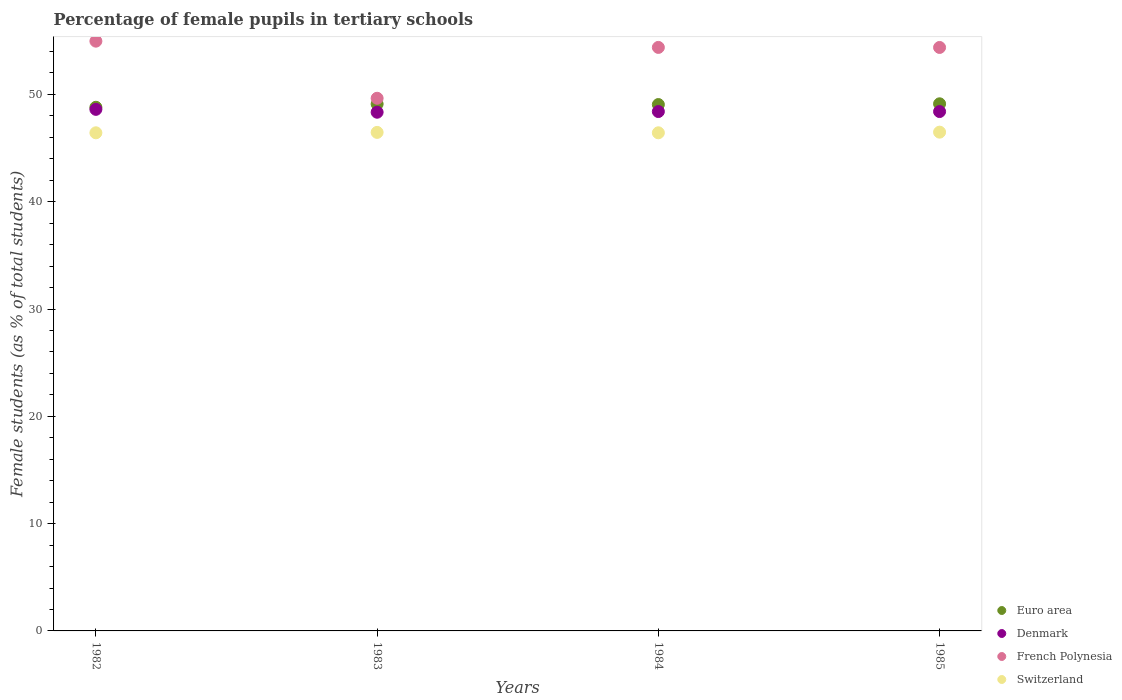How many different coloured dotlines are there?
Provide a succinct answer. 4. What is the percentage of female pupils in tertiary schools in French Polynesia in 1982?
Provide a short and direct response. 54.97. Across all years, what is the maximum percentage of female pupils in tertiary schools in Euro area?
Offer a terse response. 49.13. Across all years, what is the minimum percentage of female pupils in tertiary schools in Switzerland?
Provide a succinct answer. 46.43. In which year was the percentage of female pupils in tertiary schools in Switzerland maximum?
Keep it short and to the point. 1985. In which year was the percentage of female pupils in tertiary schools in Denmark minimum?
Make the answer very short. 1983. What is the total percentage of female pupils in tertiary schools in Denmark in the graph?
Your response must be concise. 193.77. What is the difference between the percentage of female pupils in tertiary schools in Switzerland in 1983 and that in 1985?
Ensure brevity in your answer.  -0.02. What is the difference between the percentage of female pupils in tertiary schools in Euro area in 1985 and the percentage of female pupils in tertiary schools in Switzerland in 1984?
Your response must be concise. 2.7. What is the average percentage of female pupils in tertiary schools in Euro area per year?
Your answer should be very brief. 49.02. In the year 1983, what is the difference between the percentage of female pupils in tertiary schools in Denmark and percentage of female pupils in tertiary schools in Euro area?
Ensure brevity in your answer.  -0.76. In how many years, is the percentage of female pupils in tertiary schools in Switzerland greater than 40 %?
Offer a very short reply. 4. What is the ratio of the percentage of female pupils in tertiary schools in French Polynesia in 1982 to that in 1985?
Your answer should be compact. 1.01. Is the percentage of female pupils in tertiary schools in Denmark in 1983 less than that in 1985?
Ensure brevity in your answer.  Yes. What is the difference between the highest and the second highest percentage of female pupils in tertiary schools in French Polynesia?
Provide a succinct answer. 0.58. What is the difference between the highest and the lowest percentage of female pupils in tertiary schools in French Polynesia?
Your response must be concise. 5.32. Is it the case that in every year, the sum of the percentage of female pupils in tertiary schools in French Polynesia and percentage of female pupils in tertiary schools in Denmark  is greater than the sum of percentage of female pupils in tertiary schools in Switzerland and percentage of female pupils in tertiary schools in Euro area?
Your answer should be very brief. No. Is it the case that in every year, the sum of the percentage of female pupils in tertiary schools in Euro area and percentage of female pupils in tertiary schools in Denmark  is greater than the percentage of female pupils in tertiary schools in French Polynesia?
Give a very brief answer. Yes. Is the percentage of female pupils in tertiary schools in Switzerland strictly greater than the percentage of female pupils in tertiary schools in Euro area over the years?
Keep it short and to the point. No. How many dotlines are there?
Ensure brevity in your answer.  4. What is the difference between two consecutive major ticks on the Y-axis?
Keep it short and to the point. 10. Does the graph contain grids?
Make the answer very short. No. Where does the legend appear in the graph?
Provide a succinct answer. Bottom right. How many legend labels are there?
Offer a very short reply. 4. What is the title of the graph?
Keep it short and to the point. Percentage of female pupils in tertiary schools. Does "Nepal" appear as one of the legend labels in the graph?
Offer a terse response. No. What is the label or title of the Y-axis?
Keep it short and to the point. Female students (as % of total students). What is the Female students (as % of total students) in Euro area in 1982?
Provide a succinct answer. 48.81. What is the Female students (as % of total students) of Denmark in 1982?
Provide a short and direct response. 48.61. What is the Female students (as % of total students) in French Polynesia in 1982?
Offer a very short reply. 54.97. What is the Female students (as % of total students) of Switzerland in 1982?
Keep it short and to the point. 46.43. What is the Female students (as % of total students) in Euro area in 1983?
Make the answer very short. 49.11. What is the Female students (as % of total students) of Denmark in 1983?
Keep it short and to the point. 48.34. What is the Female students (as % of total students) of French Polynesia in 1983?
Your answer should be very brief. 49.64. What is the Female students (as % of total students) of Switzerland in 1983?
Ensure brevity in your answer.  46.46. What is the Female students (as % of total students) in Euro area in 1984?
Keep it short and to the point. 49.06. What is the Female students (as % of total students) in Denmark in 1984?
Offer a very short reply. 48.41. What is the Female students (as % of total students) in French Polynesia in 1984?
Your answer should be compact. 54.38. What is the Female students (as % of total students) in Switzerland in 1984?
Your answer should be very brief. 46.43. What is the Female students (as % of total students) of Euro area in 1985?
Give a very brief answer. 49.13. What is the Female students (as % of total students) in Denmark in 1985?
Provide a short and direct response. 48.41. What is the Female students (as % of total students) in French Polynesia in 1985?
Keep it short and to the point. 54.38. What is the Female students (as % of total students) of Switzerland in 1985?
Ensure brevity in your answer.  46.49. Across all years, what is the maximum Female students (as % of total students) in Euro area?
Ensure brevity in your answer.  49.13. Across all years, what is the maximum Female students (as % of total students) in Denmark?
Ensure brevity in your answer.  48.61. Across all years, what is the maximum Female students (as % of total students) of French Polynesia?
Give a very brief answer. 54.97. Across all years, what is the maximum Female students (as % of total students) in Switzerland?
Your answer should be compact. 46.49. Across all years, what is the minimum Female students (as % of total students) of Euro area?
Keep it short and to the point. 48.81. Across all years, what is the minimum Female students (as % of total students) in Denmark?
Ensure brevity in your answer.  48.34. Across all years, what is the minimum Female students (as % of total students) in French Polynesia?
Your response must be concise. 49.64. Across all years, what is the minimum Female students (as % of total students) of Switzerland?
Offer a very short reply. 46.43. What is the total Female students (as % of total students) in Euro area in the graph?
Offer a very short reply. 196.1. What is the total Female students (as % of total students) of Denmark in the graph?
Your answer should be compact. 193.77. What is the total Female students (as % of total students) of French Polynesia in the graph?
Your answer should be compact. 213.38. What is the total Female students (as % of total students) of Switzerland in the graph?
Your answer should be very brief. 185.8. What is the difference between the Female students (as % of total students) in Euro area in 1982 and that in 1983?
Your answer should be compact. -0.3. What is the difference between the Female students (as % of total students) of Denmark in 1982 and that in 1983?
Ensure brevity in your answer.  0.27. What is the difference between the Female students (as % of total students) in French Polynesia in 1982 and that in 1983?
Provide a succinct answer. 5.32. What is the difference between the Female students (as % of total students) in Switzerland in 1982 and that in 1983?
Give a very brief answer. -0.04. What is the difference between the Female students (as % of total students) in Euro area in 1982 and that in 1984?
Ensure brevity in your answer.  -0.25. What is the difference between the Female students (as % of total students) in Denmark in 1982 and that in 1984?
Your answer should be compact. 0.2. What is the difference between the Female students (as % of total students) in French Polynesia in 1982 and that in 1984?
Keep it short and to the point. 0.58. What is the difference between the Female students (as % of total students) in Switzerland in 1982 and that in 1984?
Offer a terse response. -0. What is the difference between the Female students (as % of total students) in Euro area in 1982 and that in 1985?
Provide a succinct answer. -0.32. What is the difference between the Female students (as % of total students) in Denmark in 1982 and that in 1985?
Ensure brevity in your answer.  0.2. What is the difference between the Female students (as % of total students) in French Polynesia in 1982 and that in 1985?
Give a very brief answer. 0.59. What is the difference between the Female students (as % of total students) of Switzerland in 1982 and that in 1985?
Your response must be concise. -0.06. What is the difference between the Female students (as % of total students) of Euro area in 1983 and that in 1984?
Your answer should be compact. 0.05. What is the difference between the Female students (as % of total students) of Denmark in 1983 and that in 1984?
Give a very brief answer. -0.06. What is the difference between the Female students (as % of total students) in French Polynesia in 1983 and that in 1984?
Your response must be concise. -4.74. What is the difference between the Female students (as % of total students) in Switzerland in 1983 and that in 1984?
Ensure brevity in your answer.  0.04. What is the difference between the Female students (as % of total students) of Euro area in 1983 and that in 1985?
Ensure brevity in your answer.  -0.02. What is the difference between the Female students (as % of total students) of Denmark in 1983 and that in 1985?
Offer a very short reply. -0.06. What is the difference between the Female students (as % of total students) in French Polynesia in 1983 and that in 1985?
Provide a short and direct response. -4.74. What is the difference between the Female students (as % of total students) of Switzerland in 1983 and that in 1985?
Your response must be concise. -0.02. What is the difference between the Female students (as % of total students) in Euro area in 1984 and that in 1985?
Offer a terse response. -0.07. What is the difference between the Female students (as % of total students) of Denmark in 1984 and that in 1985?
Offer a terse response. 0. What is the difference between the Female students (as % of total students) in French Polynesia in 1984 and that in 1985?
Your answer should be very brief. 0. What is the difference between the Female students (as % of total students) of Switzerland in 1984 and that in 1985?
Your answer should be very brief. -0.06. What is the difference between the Female students (as % of total students) of Euro area in 1982 and the Female students (as % of total students) of Denmark in 1983?
Provide a succinct answer. 0.46. What is the difference between the Female students (as % of total students) in Euro area in 1982 and the Female students (as % of total students) in French Polynesia in 1983?
Keep it short and to the point. -0.84. What is the difference between the Female students (as % of total students) in Euro area in 1982 and the Female students (as % of total students) in Switzerland in 1983?
Make the answer very short. 2.34. What is the difference between the Female students (as % of total students) in Denmark in 1982 and the Female students (as % of total students) in French Polynesia in 1983?
Make the answer very short. -1.03. What is the difference between the Female students (as % of total students) of Denmark in 1982 and the Female students (as % of total students) of Switzerland in 1983?
Provide a short and direct response. 2.15. What is the difference between the Female students (as % of total students) in French Polynesia in 1982 and the Female students (as % of total students) in Switzerland in 1983?
Ensure brevity in your answer.  8.5. What is the difference between the Female students (as % of total students) of Euro area in 1982 and the Female students (as % of total students) of Denmark in 1984?
Provide a short and direct response. 0.4. What is the difference between the Female students (as % of total students) of Euro area in 1982 and the Female students (as % of total students) of French Polynesia in 1984?
Give a very brief answer. -5.58. What is the difference between the Female students (as % of total students) in Euro area in 1982 and the Female students (as % of total students) in Switzerland in 1984?
Offer a very short reply. 2.38. What is the difference between the Female students (as % of total students) in Denmark in 1982 and the Female students (as % of total students) in French Polynesia in 1984?
Offer a very short reply. -5.77. What is the difference between the Female students (as % of total students) in Denmark in 1982 and the Female students (as % of total students) in Switzerland in 1984?
Provide a short and direct response. 2.18. What is the difference between the Female students (as % of total students) in French Polynesia in 1982 and the Female students (as % of total students) in Switzerland in 1984?
Your answer should be very brief. 8.54. What is the difference between the Female students (as % of total students) in Euro area in 1982 and the Female students (as % of total students) in Denmark in 1985?
Give a very brief answer. 0.4. What is the difference between the Female students (as % of total students) of Euro area in 1982 and the Female students (as % of total students) of French Polynesia in 1985?
Give a very brief answer. -5.58. What is the difference between the Female students (as % of total students) of Euro area in 1982 and the Female students (as % of total students) of Switzerland in 1985?
Ensure brevity in your answer.  2.32. What is the difference between the Female students (as % of total students) of Denmark in 1982 and the Female students (as % of total students) of French Polynesia in 1985?
Your answer should be compact. -5.77. What is the difference between the Female students (as % of total students) of Denmark in 1982 and the Female students (as % of total students) of Switzerland in 1985?
Make the answer very short. 2.12. What is the difference between the Female students (as % of total students) in French Polynesia in 1982 and the Female students (as % of total students) in Switzerland in 1985?
Give a very brief answer. 8.48. What is the difference between the Female students (as % of total students) of Euro area in 1983 and the Female students (as % of total students) of Denmark in 1984?
Provide a succinct answer. 0.7. What is the difference between the Female students (as % of total students) of Euro area in 1983 and the Female students (as % of total students) of French Polynesia in 1984?
Provide a short and direct response. -5.28. What is the difference between the Female students (as % of total students) of Euro area in 1983 and the Female students (as % of total students) of Switzerland in 1984?
Offer a terse response. 2.68. What is the difference between the Female students (as % of total students) in Denmark in 1983 and the Female students (as % of total students) in French Polynesia in 1984?
Make the answer very short. -6.04. What is the difference between the Female students (as % of total students) in Denmark in 1983 and the Female students (as % of total students) in Switzerland in 1984?
Offer a terse response. 1.92. What is the difference between the Female students (as % of total students) of French Polynesia in 1983 and the Female students (as % of total students) of Switzerland in 1984?
Your answer should be very brief. 3.22. What is the difference between the Female students (as % of total students) of Euro area in 1983 and the Female students (as % of total students) of Denmark in 1985?
Keep it short and to the point. 0.7. What is the difference between the Female students (as % of total students) in Euro area in 1983 and the Female students (as % of total students) in French Polynesia in 1985?
Your response must be concise. -5.28. What is the difference between the Female students (as % of total students) of Euro area in 1983 and the Female students (as % of total students) of Switzerland in 1985?
Your answer should be very brief. 2.62. What is the difference between the Female students (as % of total students) of Denmark in 1983 and the Female students (as % of total students) of French Polynesia in 1985?
Offer a terse response. -6.04. What is the difference between the Female students (as % of total students) of Denmark in 1983 and the Female students (as % of total students) of Switzerland in 1985?
Make the answer very short. 1.86. What is the difference between the Female students (as % of total students) in French Polynesia in 1983 and the Female students (as % of total students) in Switzerland in 1985?
Provide a short and direct response. 3.16. What is the difference between the Female students (as % of total students) in Euro area in 1984 and the Female students (as % of total students) in Denmark in 1985?
Ensure brevity in your answer.  0.65. What is the difference between the Female students (as % of total students) in Euro area in 1984 and the Female students (as % of total students) in French Polynesia in 1985?
Give a very brief answer. -5.32. What is the difference between the Female students (as % of total students) in Euro area in 1984 and the Female students (as % of total students) in Switzerland in 1985?
Provide a short and direct response. 2.57. What is the difference between the Female students (as % of total students) of Denmark in 1984 and the Female students (as % of total students) of French Polynesia in 1985?
Keep it short and to the point. -5.97. What is the difference between the Female students (as % of total students) of Denmark in 1984 and the Female students (as % of total students) of Switzerland in 1985?
Provide a short and direct response. 1.92. What is the difference between the Female students (as % of total students) in French Polynesia in 1984 and the Female students (as % of total students) in Switzerland in 1985?
Make the answer very short. 7.9. What is the average Female students (as % of total students) in Euro area per year?
Offer a very short reply. 49.02. What is the average Female students (as % of total students) of Denmark per year?
Offer a terse response. 48.44. What is the average Female students (as % of total students) of French Polynesia per year?
Give a very brief answer. 53.34. What is the average Female students (as % of total students) of Switzerland per year?
Your answer should be compact. 46.45. In the year 1982, what is the difference between the Female students (as % of total students) of Euro area and Female students (as % of total students) of Denmark?
Provide a short and direct response. 0.19. In the year 1982, what is the difference between the Female students (as % of total students) of Euro area and Female students (as % of total students) of French Polynesia?
Your answer should be very brief. -6.16. In the year 1982, what is the difference between the Female students (as % of total students) in Euro area and Female students (as % of total students) in Switzerland?
Keep it short and to the point. 2.38. In the year 1982, what is the difference between the Female students (as % of total students) in Denmark and Female students (as % of total students) in French Polynesia?
Provide a short and direct response. -6.36. In the year 1982, what is the difference between the Female students (as % of total students) of Denmark and Female students (as % of total students) of Switzerland?
Make the answer very short. 2.19. In the year 1982, what is the difference between the Female students (as % of total students) in French Polynesia and Female students (as % of total students) in Switzerland?
Ensure brevity in your answer.  8.54. In the year 1983, what is the difference between the Female students (as % of total students) of Euro area and Female students (as % of total students) of Denmark?
Your answer should be compact. 0.76. In the year 1983, what is the difference between the Female students (as % of total students) in Euro area and Female students (as % of total students) in French Polynesia?
Your answer should be very brief. -0.54. In the year 1983, what is the difference between the Female students (as % of total students) in Euro area and Female students (as % of total students) in Switzerland?
Ensure brevity in your answer.  2.64. In the year 1983, what is the difference between the Female students (as % of total students) in Denmark and Female students (as % of total students) in French Polynesia?
Ensure brevity in your answer.  -1.3. In the year 1983, what is the difference between the Female students (as % of total students) in Denmark and Female students (as % of total students) in Switzerland?
Ensure brevity in your answer.  1.88. In the year 1983, what is the difference between the Female students (as % of total students) of French Polynesia and Female students (as % of total students) of Switzerland?
Your answer should be compact. 3.18. In the year 1984, what is the difference between the Female students (as % of total students) of Euro area and Female students (as % of total students) of Denmark?
Give a very brief answer. 0.65. In the year 1984, what is the difference between the Female students (as % of total students) in Euro area and Female students (as % of total students) in French Polynesia?
Offer a very short reply. -5.33. In the year 1984, what is the difference between the Female students (as % of total students) of Euro area and Female students (as % of total students) of Switzerland?
Ensure brevity in your answer.  2.63. In the year 1984, what is the difference between the Female students (as % of total students) of Denmark and Female students (as % of total students) of French Polynesia?
Your response must be concise. -5.98. In the year 1984, what is the difference between the Female students (as % of total students) in Denmark and Female students (as % of total students) in Switzerland?
Keep it short and to the point. 1.98. In the year 1984, what is the difference between the Female students (as % of total students) in French Polynesia and Female students (as % of total students) in Switzerland?
Provide a short and direct response. 7.96. In the year 1985, what is the difference between the Female students (as % of total students) in Euro area and Female students (as % of total students) in Denmark?
Your answer should be very brief. 0.72. In the year 1985, what is the difference between the Female students (as % of total students) in Euro area and Female students (as % of total students) in French Polynesia?
Offer a very short reply. -5.25. In the year 1985, what is the difference between the Female students (as % of total students) of Euro area and Female students (as % of total students) of Switzerland?
Offer a terse response. 2.64. In the year 1985, what is the difference between the Female students (as % of total students) of Denmark and Female students (as % of total students) of French Polynesia?
Your answer should be very brief. -5.97. In the year 1985, what is the difference between the Female students (as % of total students) in Denmark and Female students (as % of total students) in Switzerland?
Offer a very short reply. 1.92. In the year 1985, what is the difference between the Female students (as % of total students) of French Polynesia and Female students (as % of total students) of Switzerland?
Your response must be concise. 7.89. What is the ratio of the Female students (as % of total students) in Euro area in 1982 to that in 1983?
Provide a short and direct response. 0.99. What is the ratio of the Female students (as % of total students) of French Polynesia in 1982 to that in 1983?
Ensure brevity in your answer.  1.11. What is the ratio of the Female students (as % of total students) of Euro area in 1982 to that in 1984?
Provide a succinct answer. 0.99. What is the ratio of the Female students (as % of total students) of Denmark in 1982 to that in 1984?
Your answer should be compact. 1. What is the ratio of the Female students (as % of total students) of French Polynesia in 1982 to that in 1984?
Your answer should be compact. 1.01. What is the ratio of the Female students (as % of total students) of Switzerland in 1982 to that in 1984?
Ensure brevity in your answer.  1. What is the ratio of the Female students (as % of total students) of Euro area in 1982 to that in 1985?
Keep it short and to the point. 0.99. What is the ratio of the Female students (as % of total students) in Denmark in 1982 to that in 1985?
Your answer should be compact. 1. What is the ratio of the Female students (as % of total students) of French Polynesia in 1982 to that in 1985?
Your answer should be compact. 1.01. What is the ratio of the Female students (as % of total students) in Switzerland in 1982 to that in 1985?
Your answer should be very brief. 1. What is the ratio of the Female students (as % of total students) in Denmark in 1983 to that in 1984?
Offer a terse response. 1. What is the ratio of the Female students (as % of total students) of French Polynesia in 1983 to that in 1984?
Give a very brief answer. 0.91. What is the ratio of the Female students (as % of total students) of Euro area in 1983 to that in 1985?
Offer a terse response. 1. What is the ratio of the Female students (as % of total students) in Denmark in 1983 to that in 1985?
Offer a terse response. 1. What is the ratio of the Female students (as % of total students) of French Polynesia in 1983 to that in 1985?
Your answer should be very brief. 0.91. What is the ratio of the Female students (as % of total students) of Switzerland in 1983 to that in 1985?
Provide a short and direct response. 1. What is the ratio of the Female students (as % of total students) in Denmark in 1984 to that in 1985?
Provide a short and direct response. 1. What is the ratio of the Female students (as % of total students) in French Polynesia in 1984 to that in 1985?
Keep it short and to the point. 1. What is the ratio of the Female students (as % of total students) in Switzerland in 1984 to that in 1985?
Make the answer very short. 1. What is the difference between the highest and the second highest Female students (as % of total students) in Euro area?
Give a very brief answer. 0.02. What is the difference between the highest and the second highest Female students (as % of total students) in Denmark?
Make the answer very short. 0.2. What is the difference between the highest and the second highest Female students (as % of total students) of French Polynesia?
Offer a very short reply. 0.58. What is the difference between the highest and the second highest Female students (as % of total students) of Switzerland?
Your answer should be very brief. 0.02. What is the difference between the highest and the lowest Female students (as % of total students) in Euro area?
Offer a very short reply. 0.32. What is the difference between the highest and the lowest Female students (as % of total students) of Denmark?
Make the answer very short. 0.27. What is the difference between the highest and the lowest Female students (as % of total students) of French Polynesia?
Offer a terse response. 5.32. What is the difference between the highest and the lowest Female students (as % of total students) in Switzerland?
Keep it short and to the point. 0.06. 